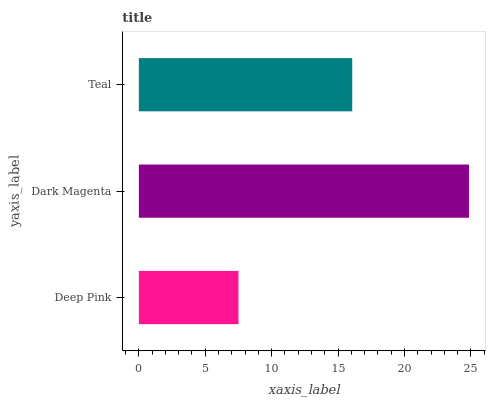Is Deep Pink the minimum?
Answer yes or no. Yes. Is Dark Magenta the maximum?
Answer yes or no. Yes. Is Teal the minimum?
Answer yes or no. No. Is Teal the maximum?
Answer yes or no. No. Is Dark Magenta greater than Teal?
Answer yes or no. Yes. Is Teal less than Dark Magenta?
Answer yes or no. Yes. Is Teal greater than Dark Magenta?
Answer yes or no. No. Is Dark Magenta less than Teal?
Answer yes or no. No. Is Teal the high median?
Answer yes or no. Yes. Is Teal the low median?
Answer yes or no. Yes. Is Deep Pink the high median?
Answer yes or no. No. Is Dark Magenta the low median?
Answer yes or no. No. 